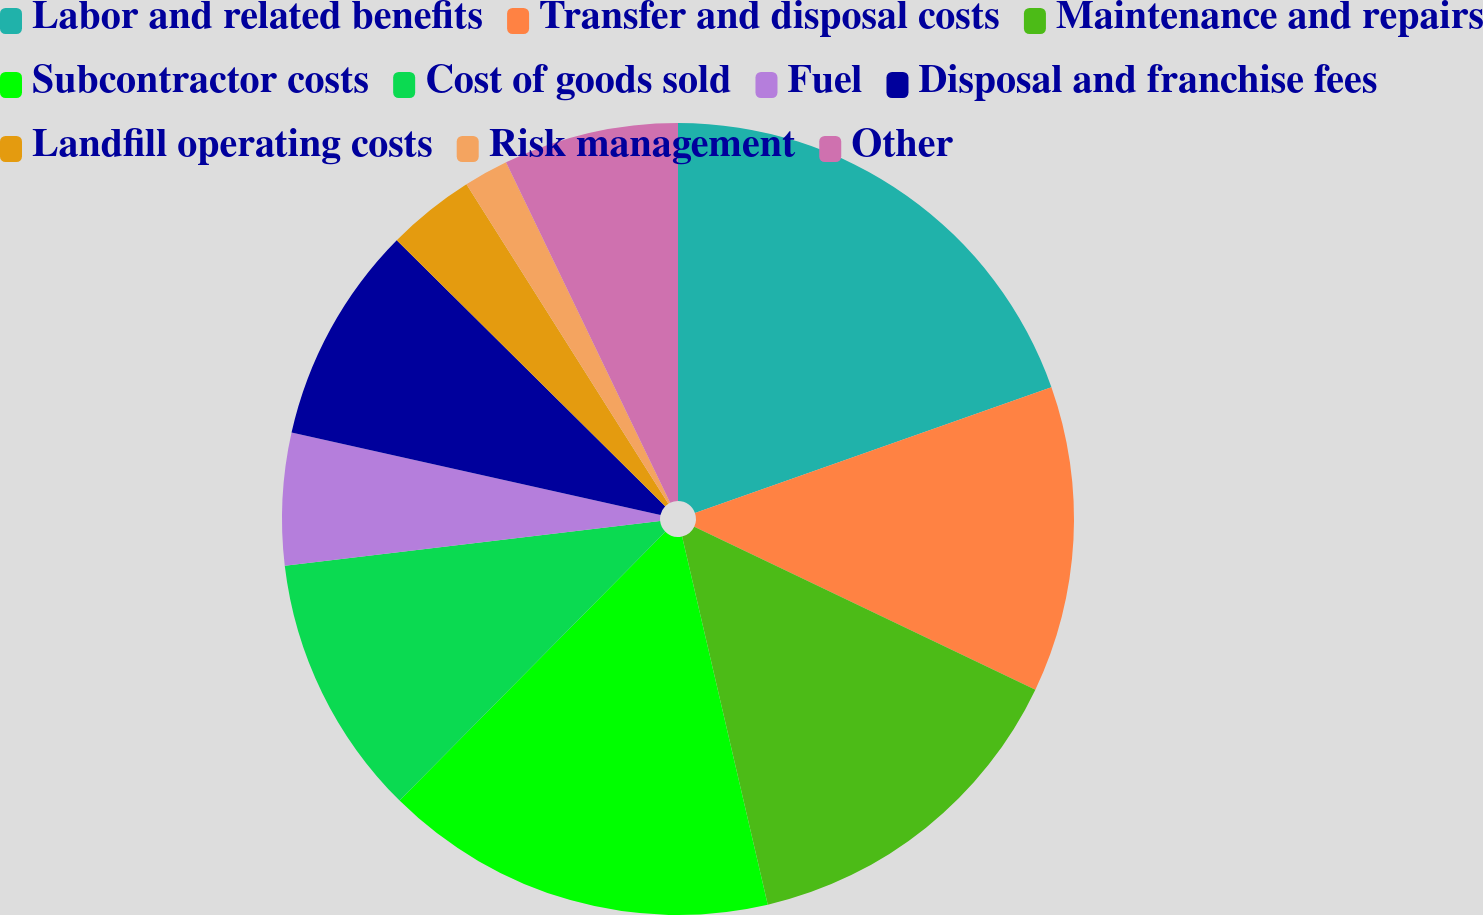Convert chart. <chart><loc_0><loc_0><loc_500><loc_500><pie_chart><fcel>Labor and related benefits<fcel>Transfer and disposal costs<fcel>Maintenance and repairs<fcel>Subcontractor costs<fcel>Cost of goods sold<fcel>Fuel<fcel>Disposal and franchise fees<fcel>Landfill operating costs<fcel>Risk management<fcel>Other<nl><fcel>19.6%<fcel>12.49%<fcel>14.27%<fcel>16.05%<fcel>10.71%<fcel>5.38%<fcel>8.93%<fcel>3.6%<fcel>1.82%<fcel>7.15%<nl></chart> 